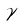<formula> <loc_0><loc_0><loc_500><loc_500>\tilde { \gamma }</formula> 